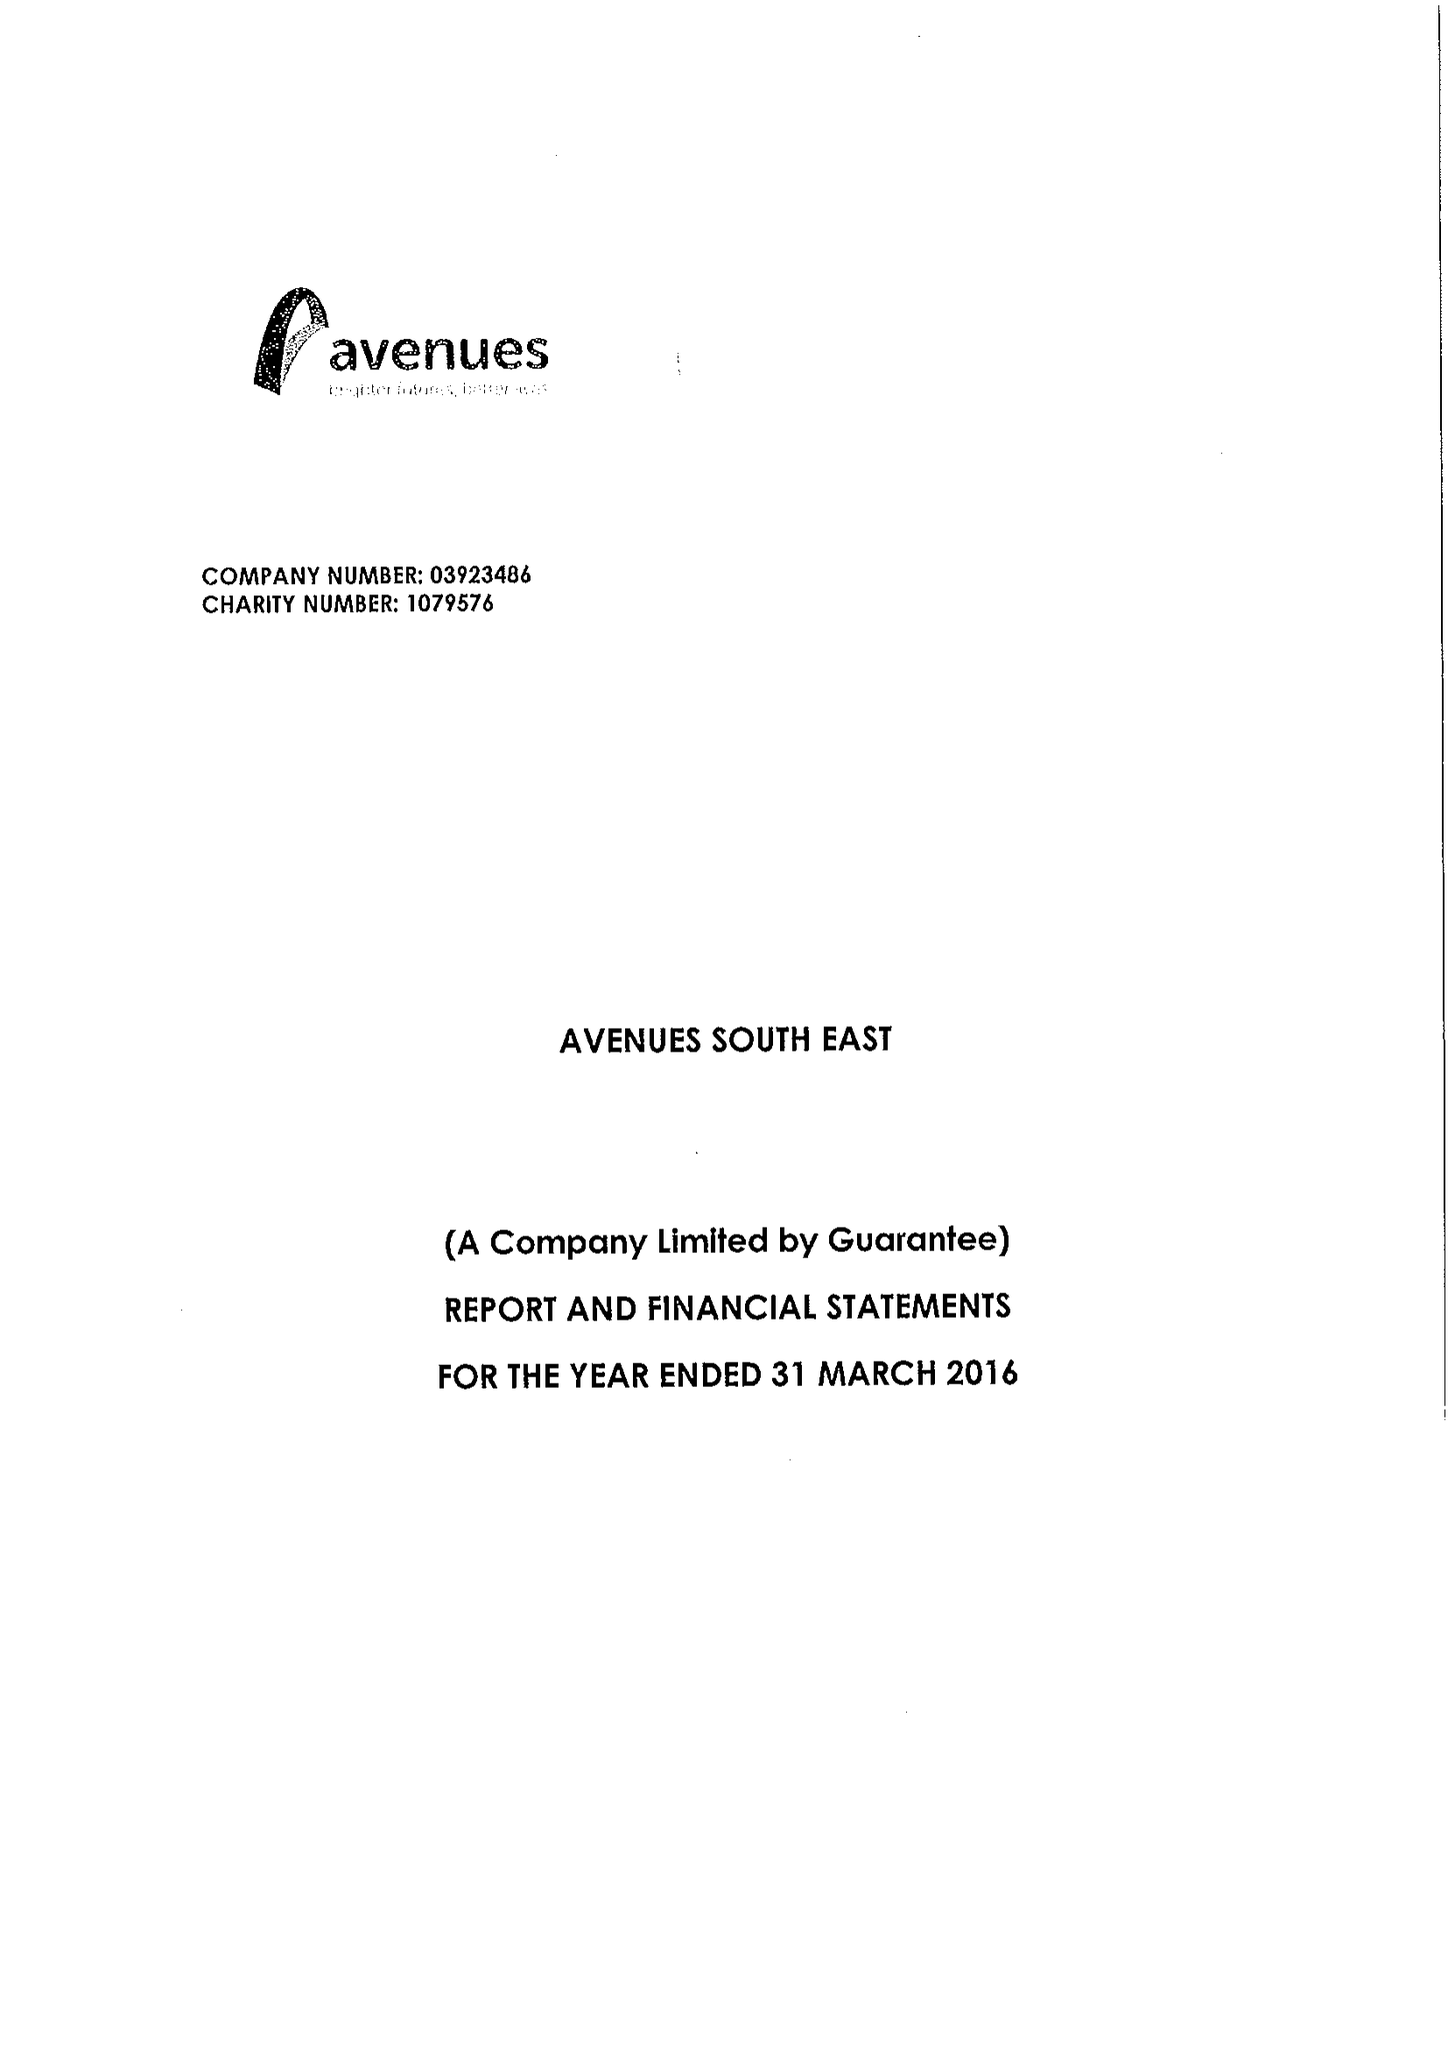What is the value for the address__post_town?
Answer the question using a single word or phrase. SIDCUP 